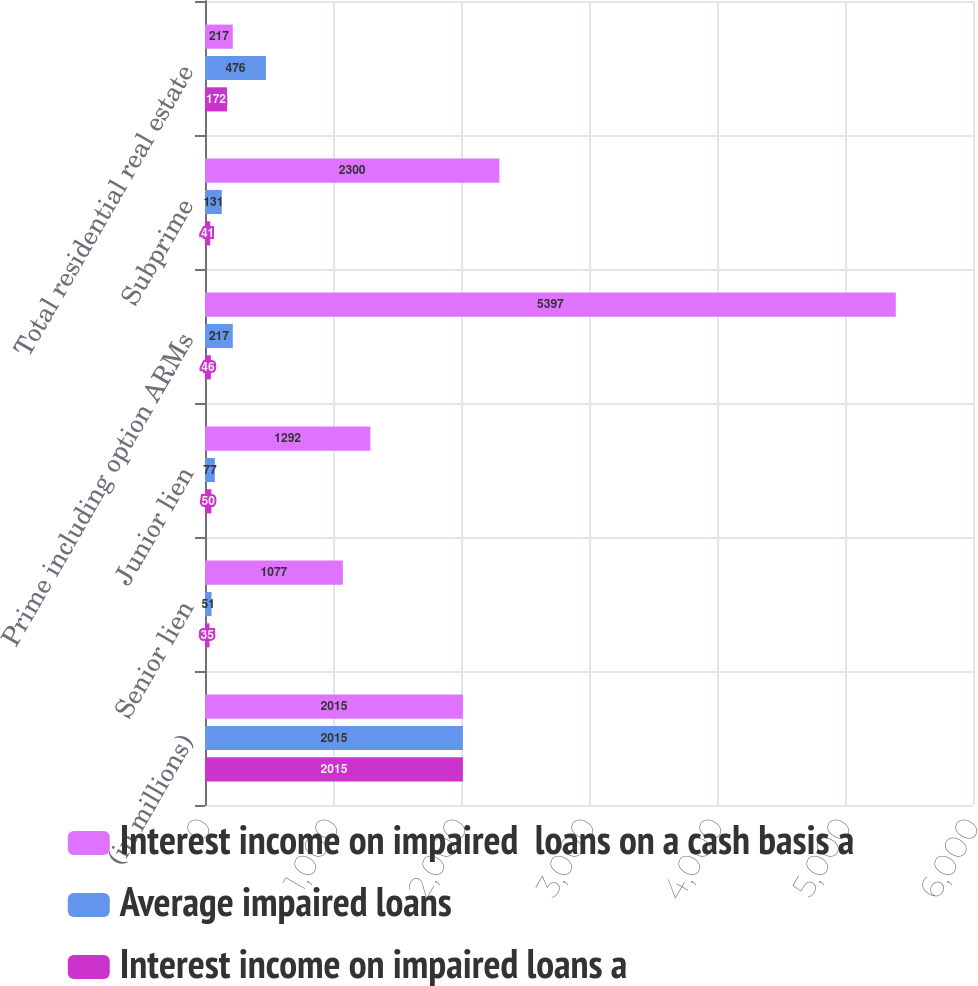Convert chart to OTSL. <chart><loc_0><loc_0><loc_500><loc_500><stacked_bar_chart><ecel><fcel>(in millions)<fcel>Senior lien<fcel>Junior lien<fcel>Prime including option ARMs<fcel>Subprime<fcel>Total residential real estate<nl><fcel>Interest income on impaired  loans on a cash basis a<fcel>2015<fcel>1077<fcel>1292<fcel>5397<fcel>2300<fcel>217<nl><fcel>Average impaired loans<fcel>2015<fcel>51<fcel>77<fcel>217<fcel>131<fcel>476<nl><fcel>Interest income on impaired loans a<fcel>2015<fcel>35<fcel>50<fcel>46<fcel>41<fcel>172<nl></chart> 